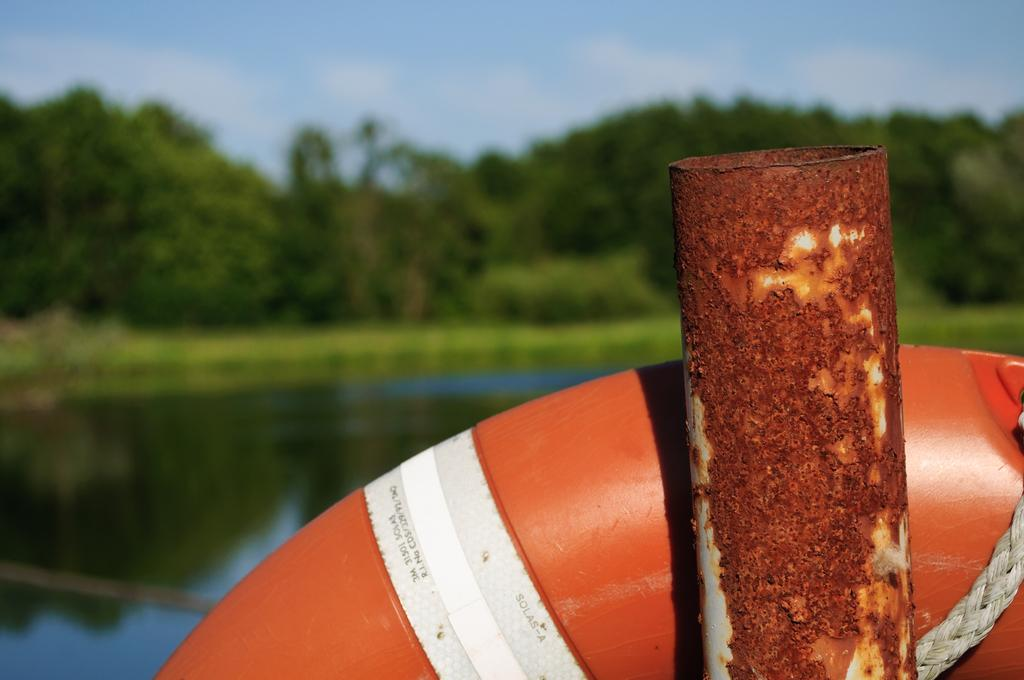What type of object is present in the image? There is a metal pipe in the image. What else can be seen in the image besides the metal pipe? There are objects, water, grass, and trees visible in the image. What is the background of the image? The background of the image includes trees and the sky. Can you describe the setting of the image? The image may have been taken near a lake, as there is water visible and the presence of trees suggests a natural environment. What type of linen is draped over the metal pipe in the image? There is no linen present in the image; it only features a metal pipe, objects, water, grass, trees, and the sky. 